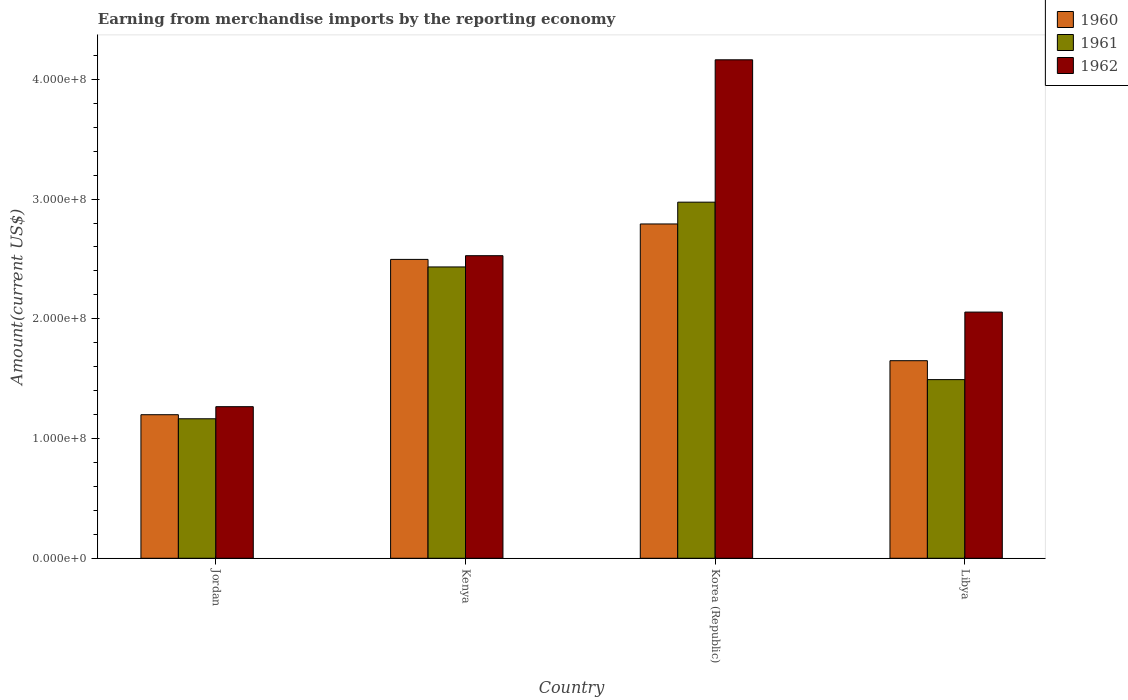How many groups of bars are there?
Your response must be concise. 4. Are the number of bars on each tick of the X-axis equal?
Provide a short and direct response. Yes. How many bars are there on the 3rd tick from the right?
Give a very brief answer. 3. What is the label of the 2nd group of bars from the left?
Ensure brevity in your answer.  Kenya. In how many cases, is the number of bars for a given country not equal to the number of legend labels?
Your answer should be compact. 0. What is the amount earned from merchandise imports in 1960 in Jordan?
Make the answer very short. 1.20e+08. Across all countries, what is the maximum amount earned from merchandise imports in 1962?
Offer a very short reply. 4.16e+08. Across all countries, what is the minimum amount earned from merchandise imports in 1960?
Offer a very short reply. 1.20e+08. In which country was the amount earned from merchandise imports in 1961 minimum?
Provide a succinct answer. Jordan. What is the total amount earned from merchandise imports in 1961 in the graph?
Offer a very short reply. 8.06e+08. What is the difference between the amount earned from merchandise imports in 1962 in Kenya and that in Libya?
Make the answer very short. 4.71e+07. What is the difference between the amount earned from merchandise imports in 1960 in Libya and the amount earned from merchandise imports in 1961 in Korea (Republic)?
Make the answer very short. -1.32e+08. What is the average amount earned from merchandise imports in 1961 per country?
Keep it short and to the point. 2.02e+08. What is the difference between the amount earned from merchandise imports of/in 1962 and amount earned from merchandise imports of/in 1960 in Libya?
Provide a short and direct response. 4.06e+07. What is the ratio of the amount earned from merchandise imports in 1960 in Jordan to that in Libya?
Your answer should be compact. 0.73. What is the difference between the highest and the second highest amount earned from merchandise imports in 1960?
Make the answer very short. 2.96e+07. What is the difference between the highest and the lowest amount earned from merchandise imports in 1962?
Your answer should be compact. 2.90e+08. What does the 1st bar from the left in Kenya represents?
Provide a succinct answer. 1960. How many bars are there?
Your answer should be compact. 12. Are all the bars in the graph horizontal?
Give a very brief answer. No. What is the difference between two consecutive major ticks on the Y-axis?
Give a very brief answer. 1.00e+08. Are the values on the major ticks of Y-axis written in scientific E-notation?
Give a very brief answer. Yes. Does the graph contain any zero values?
Offer a terse response. No. Where does the legend appear in the graph?
Offer a very short reply. Top right. How many legend labels are there?
Ensure brevity in your answer.  3. What is the title of the graph?
Offer a terse response. Earning from merchandise imports by the reporting economy. Does "1966" appear as one of the legend labels in the graph?
Provide a short and direct response. No. What is the label or title of the Y-axis?
Provide a succinct answer. Amount(current US$). What is the Amount(current US$) of 1960 in Jordan?
Your response must be concise. 1.20e+08. What is the Amount(current US$) of 1961 in Jordan?
Provide a succinct answer. 1.16e+08. What is the Amount(current US$) in 1962 in Jordan?
Give a very brief answer. 1.27e+08. What is the Amount(current US$) in 1960 in Kenya?
Offer a very short reply. 2.50e+08. What is the Amount(current US$) in 1961 in Kenya?
Ensure brevity in your answer.  2.43e+08. What is the Amount(current US$) of 1962 in Kenya?
Your answer should be compact. 2.53e+08. What is the Amount(current US$) in 1960 in Korea (Republic)?
Give a very brief answer. 2.79e+08. What is the Amount(current US$) in 1961 in Korea (Republic)?
Your answer should be very brief. 2.97e+08. What is the Amount(current US$) of 1962 in Korea (Republic)?
Give a very brief answer. 4.16e+08. What is the Amount(current US$) in 1960 in Libya?
Give a very brief answer. 1.65e+08. What is the Amount(current US$) in 1961 in Libya?
Keep it short and to the point. 1.49e+08. What is the Amount(current US$) in 1962 in Libya?
Keep it short and to the point. 2.06e+08. Across all countries, what is the maximum Amount(current US$) in 1960?
Your answer should be very brief. 2.79e+08. Across all countries, what is the maximum Amount(current US$) in 1961?
Give a very brief answer. 2.97e+08. Across all countries, what is the maximum Amount(current US$) in 1962?
Provide a succinct answer. 4.16e+08. Across all countries, what is the minimum Amount(current US$) of 1960?
Keep it short and to the point. 1.20e+08. Across all countries, what is the minimum Amount(current US$) in 1961?
Your response must be concise. 1.16e+08. Across all countries, what is the minimum Amount(current US$) in 1962?
Your answer should be compact. 1.27e+08. What is the total Amount(current US$) of 1960 in the graph?
Ensure brevity in your answer.  8.14e+08. What is the total Amount(current US$) in 1961 in the graph?
Make the answer very short. 8.06e+08. What is the total Amount(current US$) in 1962 in the graph?
Give a very brief answer. 1.00e+09. What is the difference between the Amount(current US$) of 1960 in Jordan and that in Kenya?
Ensure brevity in your answer.  -1.30e+08. What is the difference between the Amount(current US$) in 1961 in Jordan and that in Kenya?
Offer a terse response. -1.27e+08. What is the difference between the Amount(current US$) in 1962 in Jordan and that in Kenya?
Offer a very short reply. -1.26e+08. What is the difference between the Amount(current US$) of 1960 in Jordan and that in Korea (Republic)?
Ensure brevity in your answer.  -1.59e+08. What is the difference between the Amount(current US$) in 1961 in Jordan and that in Korea (Republic)?
Offer a terse response. -1.81e+08. What is the difference between the Amount(current US$) of 1962 in Jordan and that in Korea (Republic)?
Offer a very short reply. -2.90e+08. What is the difference between the Amount(current US$) of 1960 in Jordan and that in Libya?
Your answer should be very brief. -4.51e+07. What is the difference between the Amount(current US$) of 1961 in Jordan and that in Libya?
Provide a short and direct response. -3.27e+07. What is the difference between the Amount(current US$) of 1962 in Jordan and that in Libya?
Your answer should be compact. -7.90e+07. What is the difference between the Amount(current US$) of 1960 in Kenya and that in Korea (Republic)?
Offer a terse response. -2.96e+07. What is the difference between the Amount(current US$) of 1961 in Kenya and that in Korea (Republic)?
Keep it short and to the point. -5.41e+07. What is the difference between the Amount(current US$) of 1962 in Kenya and that in Korea (Republic)?
Give a very brief answer. -1.64e+08. What is the difference between the Amount(current US$) in 1960 in Kenya and that in Libya?
Ensure brevity in your answer.  8.46e+07. What is the difference between the Amount(current US$) of 1961 in Kenya and that in Libya?
Give a very brief answer. 9.41e+07. What is the difference between the Amount(current US$) of 1962 in Kenya and that in Libya?
Offer a terse response. 4.71e+07. What is the difference between the Amount(current US$) in 1960 in Korea (Republic) and that in Libya?
Your response must be concise. 1.14e+08. What is the difference between the Amount(current US$) of 1961 in Korea (Republic) and that in Libya?
Your answer should be compact. 1.48e+08. What is the difference between the Amount(current US$) of 1962 in Korea (Republic) and that in Libya?
Provide a succinct answer. 2.11e+08. What is the difference between the Amount(current US$) of 1960 in Jordan and the Amount(current US$) of 1961 in Kenya?
Offer a terse response. -1.23e+08. What is the difference between the Amount(current US$) in 1960 in Jordan and the Amount(current US$) in 1962 in Kenya?
Provide a succinct answer. -1.33e+08. What is the difference between the Amount(current US$) of 1961 in Jordan and the Amount(current US$) of 1962 in Kenya?
Offer a very short reply. -1.36e+08. What is the difference between the Amount(current US$) of 1960 in Jordan and the Amount(current US$) of 1961 in Korea (Republic)?
Offer a very short reply. -1.78e+08. What is the difference between the Amount(current US$) of 1960 in Jordan and the Amount(current US$) of 1962 in Korea (Republic)?
Your answer should be very brief. -2.96e+08. What is the difference between the Amount(current US$) of 1961 in Jordan and the Amount(current US$) of 1962 in Korea (Republic)?
Provide a succinct answer. -3.00e+08. What is the difference between the Amount(current US$) of 1960 in Jordan and the Amount(current US$) of 1961 in Libya?
Keep it short and to the point. -2.93e+07. What is the difference between the Amount(current US$) in 1960 in Jordan and the Amount(current US$) in 1962 in Libya?
Your answer should be very brief. -8.57e+07. What is the difference between the Amount(current US$) in 1961 in Jordan and the Amount(current US$) in 1962 in Libya?
Give a very brief answer. -8.91e+07. What is the difference between the Amount(current US$) in 1960 in Kenya and the Amount(current US$) in 1961 in Korea (Republic)?
Offer a very short reply. -4.78e+07. What is the difference between the Amount(current US$) of 1960 in Kenya and the Amount(current US$) of 1962 in Korea (Republic)?
Ensure brevity in your answer.  -1.67e+08. What is the difference between the Amount(current US$) in 1961 in Kenya and the Amount(current US$) in 1962 in Korea (Republic)?
Your answer should be very brief. -1.73e+08. What is the difference between the Amount(current US$) of 1960 in Kenya and the Amount(current US$) of 1961 in Libya?
Make the answer very short. 1.00e+08. What is the difference between the Amount(current US$) in 1960 in Kenya and the Amount(current US$) in 1962 in Libya?
Make the answer very short. 4.40e+07. What is the difference between the Amount(current US$) of 1961 in Kenya and the Amount(current US$) of 1962 in Libya?
Make the answer very short. 3.77e+07. What is the difference between the Amount(current US$) of 1960 in Korea (Republic) and the Amount(current US$) of 1961 in Libya?
Offer a terse response. 1.30e+08. What is the difference between the Amount(current US$) in 1960 in Korea (Republic) and the Amount(current US$) in 1962 in Libya?
Ensure brevity in your answer.  7.36e+07. What is the difference between the Amount(current US$) of 1961 in Korea (Republic) and the Amount(current US$) of 1962 in Libya?
Your response must be concise. 9.18e+07. What is the average Amount(current US$) of 1960 per country?
Provide a short and direct response. 2.03e+08. What is the average Amount(current US$) in 1961 per country?
Ensure brevity in your answer.  2.02e+08. What is the average Amount(current US$) in 1962 per country?
Your answer should be very brief. 2.50e+08. What is the difference between the Amount(current US$) in 1960 and Amount(current US$) in 1961 in Jordan?
Keep it short and to the point. 3.40e+06. What is the difference between the Amount(current US$) of 1960 and Amount(current US$) of 1962 in Jordan?
Your answer should be very brief. -6.70e+06. What is the difference between the Amount(current US$) of 1961 and Amount(current US$) of 1962 in Jordan?
Keep it short and to the point. -1.01e+07. What is the difference between the Amount(current US$) in 1960 and Amount(current US$) in 1961 in Kenya?
Make the answer very short. 6.30e+06. What is the difference between the Amount(current US$) of 1960 and Amount(current US$) of 1962 in Kenya?
Make the answer very short. -3.10e+06. What is the difference between the Amount(current US$) in 1961 and Amount(current US$) in 1962 in Kenya?
Keep it short and to the point. -9.40e+06. What is the difference between the Amount(current US$) of 1960 and Amount(current US$) of 1961 in Korea (Republic)?
Your answer should be very brief. -1.82e+07. What is the difference between the Amount(current US$) in 1960 and Amount(current US$) in 1962 in Korea (Republic)?
Ensure brevity in your answer.  -1.37e+08. What is the difference between the Amount(current US$) of 1961 and Amount(current US$) of 1962 in Korea (Republic)?
Ensure brevity in your answer.  -1.19e+08. What is the difference between the Amount(current US$) of 1960 and Amount(current US$) of 1961 in Libya?
Provide a short and direct response. 1.58e+07. What is the difference between the Amount(current US$) in 1960 and Amount(current US$) in 1962 in Libya?
Your response must be concise. -4.06e+07. What is the difference between the Amount(current US$) in 1961 and Amount(current US$) in 1962 in Libya?
Provide a succinct answer. -5.64e+07. What is the ratio of the Amount(current US$) in 1960 in Jordan to that in Kenya?
Provide a succinct answer. 0.48. What is the ratio of the Amount(current US$) of 1961 in Jordan to that in Kenya?
Your response must be concise. 0.48. What is the ratio of the Amount(current US$) of 1962 in Jordan to that in Kenya?
Your answer should be very brief. 0.5. What is the ratio of the Amount(current US$) in 1960 in Jordan to that in Korea (Republic)?
Provide a short and direct response. 0.43. What is the ratio of the Amount(current US$) of 1961 in Jordan to that in Korea (Republic)?
Provide a succinct answer. 0.39. What is the ratio of the Amount(current US$) of 1962 in Jordan to that in Korea (Republic)?
Ensure brevity in your answer.  0.3. What is the ratio of the Amount(current US$) of 1960 in Jordan to that in Libya?
Keep it short and to the point. 0.73. What is the ratio of the Amount(current US$) of 1961 in Jordan to that in Libya?
Keep it short and to the point. 0.78. What is the ratio of the Amount(current US$) in 1962 in Jordan to that in Libya?
Give a very brief answer. 0.62. What is the ratio of the Amount(current US$) in 1960 in Kenya to that in Korea (Republic)?
Keep it short and to the point. 0.89. What is the ratio of the Amount(current US$) of 1961 in Kenya to that in Korea (Republic)?
Your answer should be very brief. 0.82. What is the ratio of the Amount(current US$) in 1962 in Kenya to that in Korea (Republic)?
Keep it short and to the point. 0.61. What is the ratio of the Amount(current US$) in 1960 in Kenya to that in Libya?
Provide a succinct answer. 1.51. What is the ratio of the Amount(current US$) of 1961 in Kenya to that in Libya?
Provide a succinct answer. 1.63. What is the ratio of the Amount(current US$) in 1962 in Kenya to that in Libya?
Your answer should be compact. 1.23. What is the ratio of the Amount(current US$) in 1960 in Korea (Republic) to that in Libya?
Provide a short and direct response. 1.69. What is the ratio of the Amount(current US$) of 1961 in Korea (Republic) to that in Libya?
Ensure brevity in your answer.  1.99. What is the ratio of the Amount(current US$) in 1962 in Korea (Republic) to that in Libya?
Make the answer very short. 2.02. What is the difference between the highest and the second highest Amount(current US$) in 1960?
Offer a very short reply. 2.96e+07. What is the difference between the highest and the second highest Amount(current US$) of 1961?
Your answer should be very brief. 5.41e+07. What is the difference between the highest and the second highest Amount(current US$) of 1962?
Provide a succinct answer. 1.64e+08. What is the difference between the highest and the lowest Amount(current US$) of 1960?
Ensure brevity in your answer.  1.59e+08. What is the difference between the highest and the lowest Amount(current US$) in 1961?
Keep it short and to the point. 1.81e+08. What is the difference between the highest and the lowest Amount(current US$) of 1962?
Make the answer very short. 2.90e+08. 